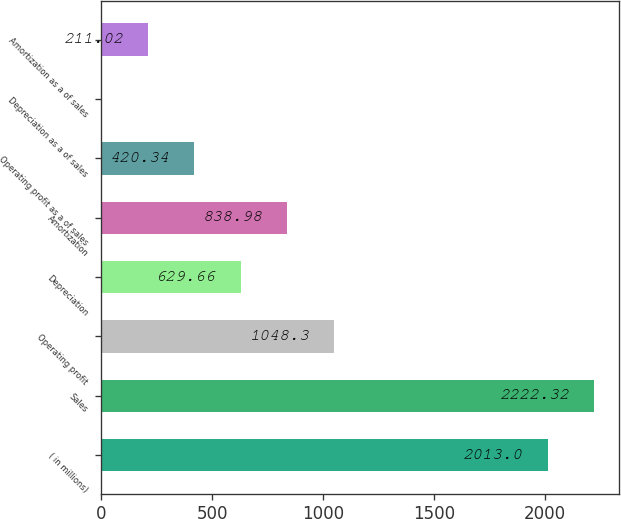Convert chart. <chart><loc_0><loc_0><loc_500><loc_500><bar_chart><fcel>( in millions)<fcel>Sales<fcel>Operating profit<fcel>Depreciation<fcel>Amortization<fcel>Operating profit as a of sales<fcel>Depreciation as a of sales<fcel>Amortization as a of sales<nl><fcel>2013<fcel>2222.32<fcel>1048.3<fcel>629.66<fcel>838.98<fcel>420.34<fcel>1.7<fcel>211.02<nl></chart> 